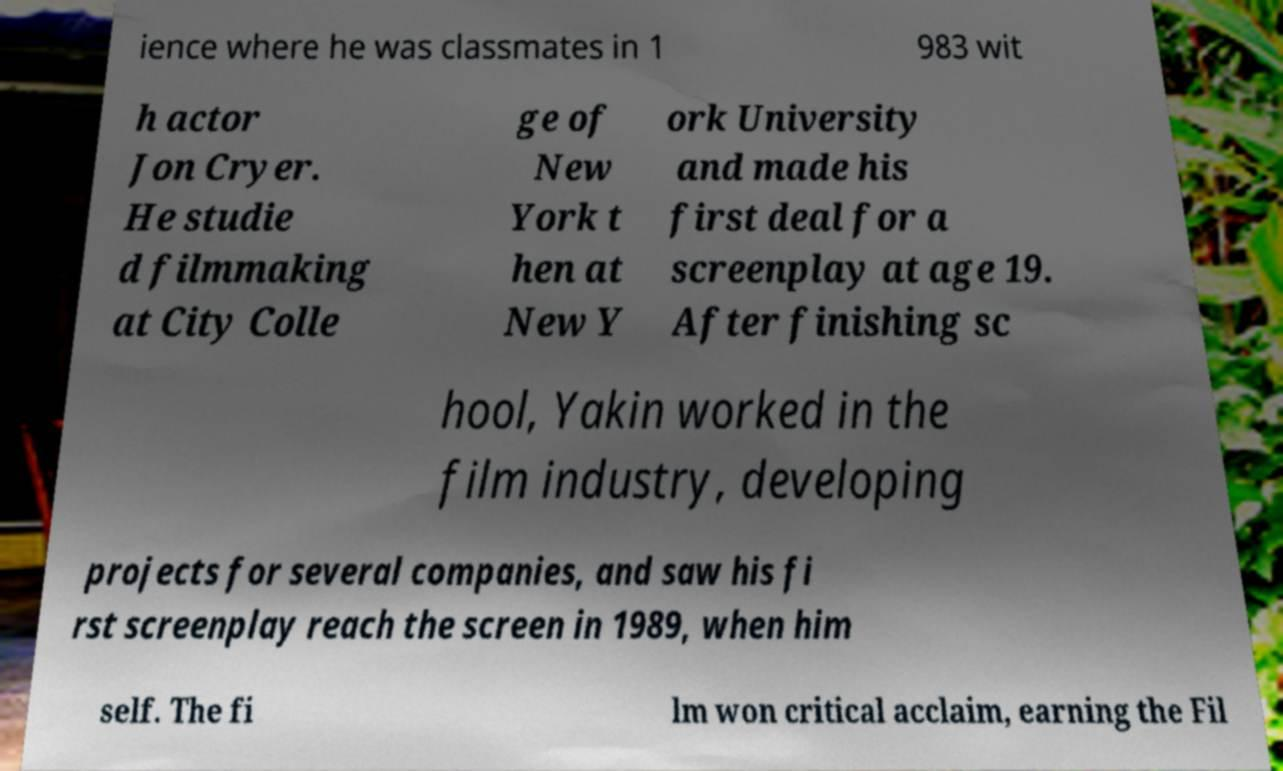Please identify and transcribe the text found in this image. ience where he was classmates in 1 983 wit h actor Jon Cryer. He studie d filmmaking at City Colle ge of New York t hen at New Y ork University and made his first deal for a screenplay at age 19. After finishing sc hool, Yakin worked in the film industry, developing projects for several companies, and saw his fi rst screenplay reach the screen in 1989, when him self. The fi lm won critical acclaim, earning the Fil 